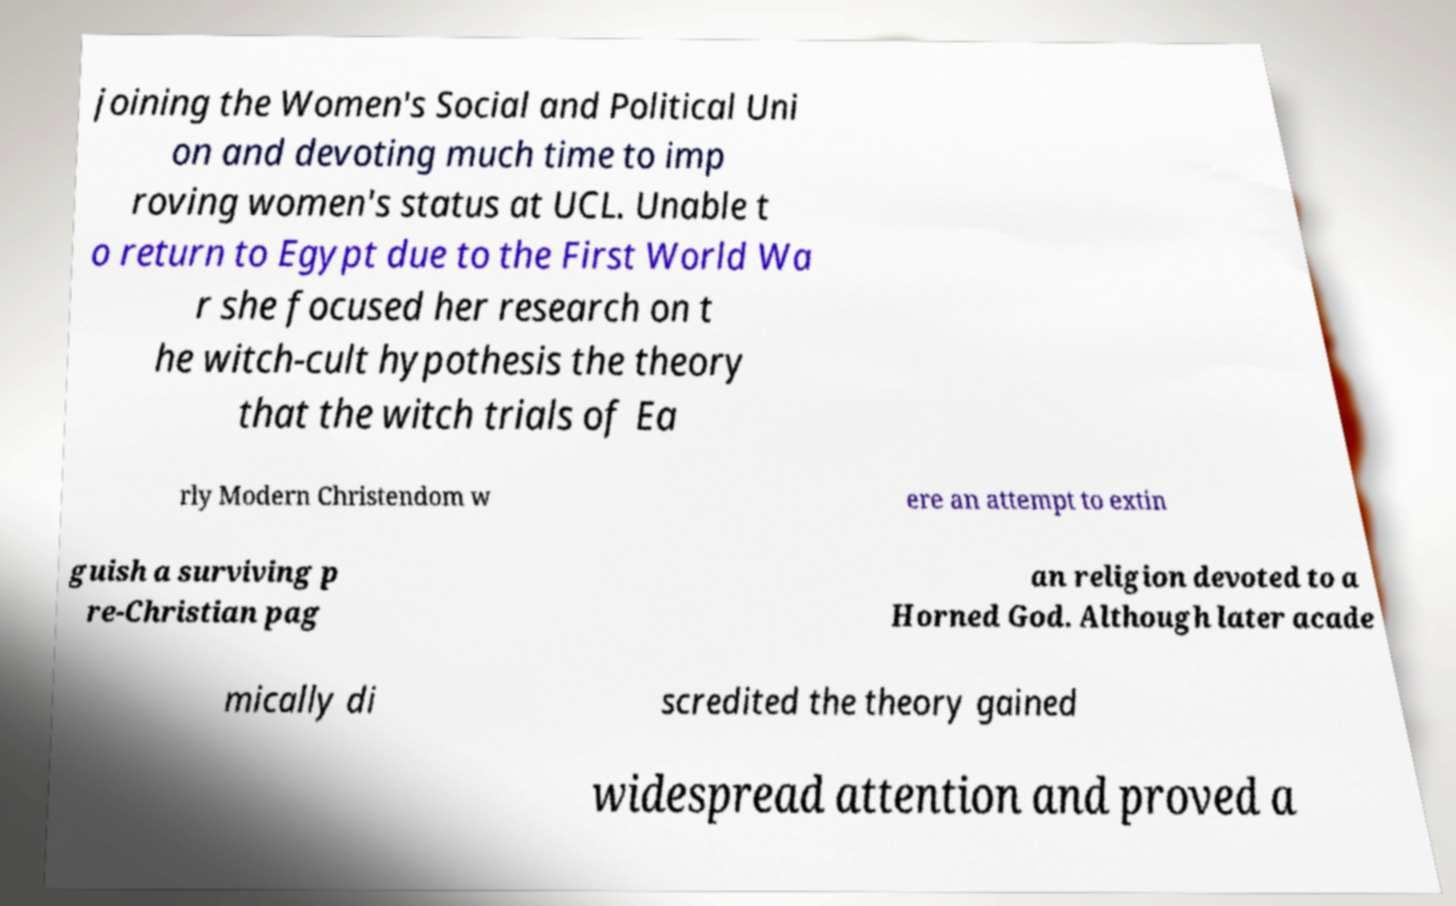Please read and relay the text visible in this image. What does it say? joining the Women's Social and Political Uni on and devoting much time to imp roving women's status at UCL. Unable t o return to Egypt due to the First World Wa r she focused her research on t he witch-cult hypothesis the theory that the witch trials of Ea rly Modern Christendom w ere an attempt to extin guish a surviving p re-Christian pag an religion devoted to a Horned God. Although later acade mically di scredited the theory gained widespread attention and proved a 